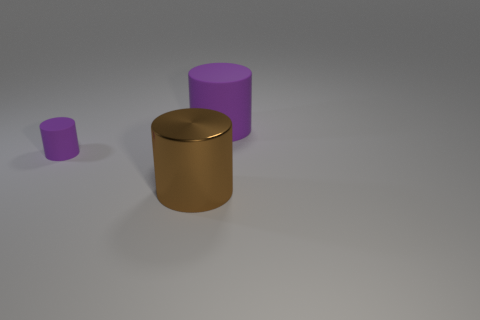Add 2 small purple cylinders. How many objects exist? 5 Add 2 large cyan blocks. How many large cyan blocks exist? 2 Subtract 0 yellow blocks. How many objects are left? 3 Subtract all big red matte cylinders. Subtract all rubber cylinders. How many objects are left? 1 Add 1 brown cylinders. How many brown cylinders are left? 2 